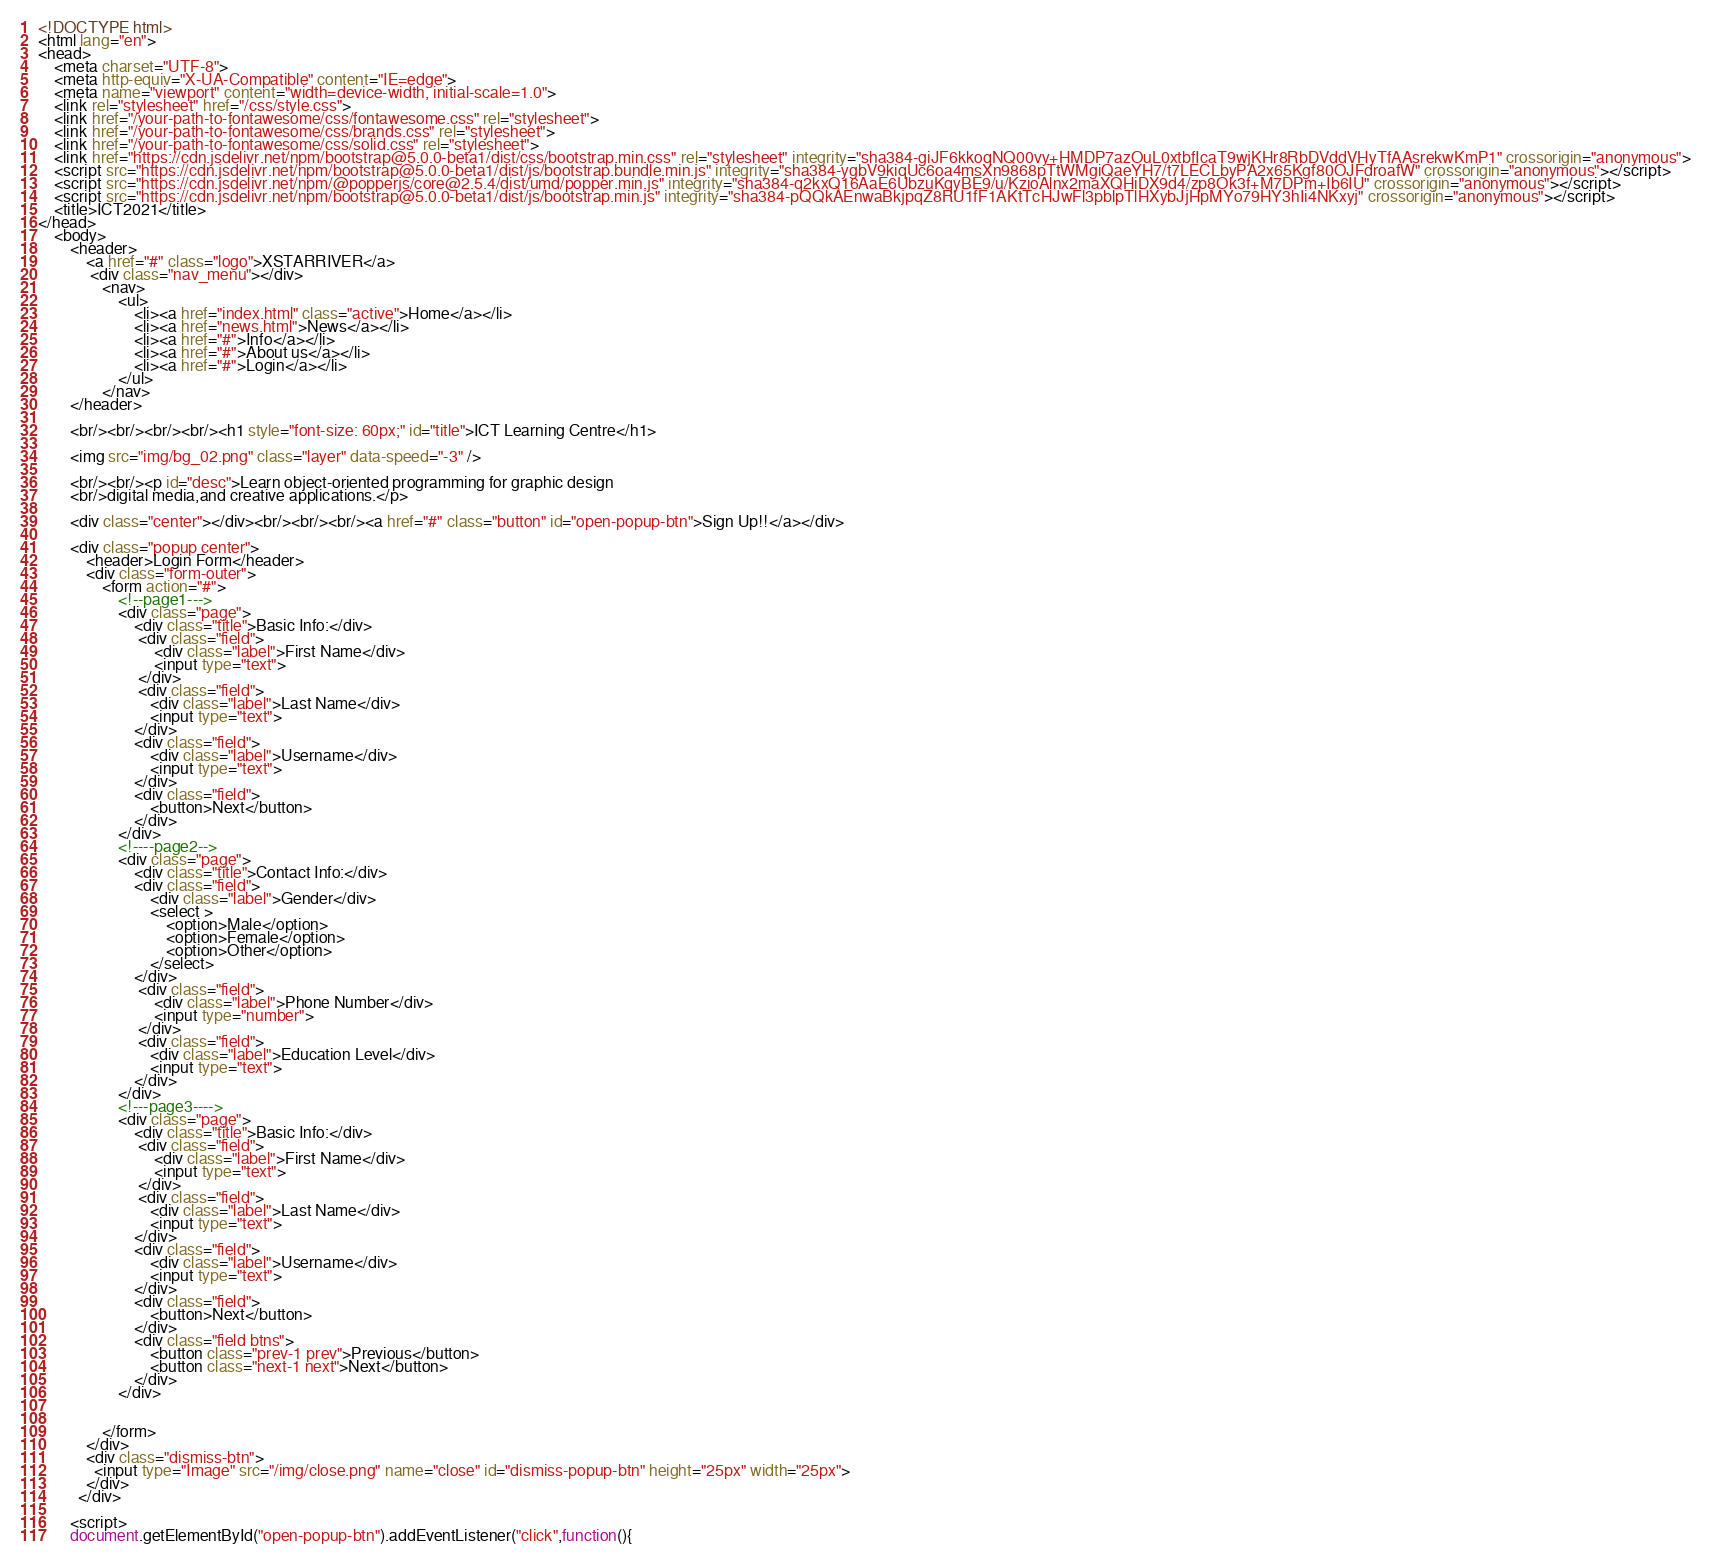Convert code to text. <code><loc_0><loc_0><loc_500><loc_500><_HTML_><!DOCTYPE html>
<html lang="en">
<head>
    <meta charset="UTF-8">
    <meta http-equiv="X-UA-Compatible" content="IE=edge">
    <meta name="viewport" content="width=device-width, initial-scale=1.0">
    <link rel="stylesheet" href="/css/style.css">
    <link href="/your-path-to-fontawesome/css/fontawesome.css" rel="stylesheet">
    <link href="/your-path-to-fontawesome/css/brands.css" rel="stylesheet">
    <link href="/your-path-to-fontawesome/css/solid.css" rel="stylesheet">
    <link href="https://cdn.jsdelivr.net/npm/bootstrap@5.0.0-beta1/dist/css/bootstrap.min.css" rel="stylesheet" integrity="sha384-giJF6kkoqNQ00vy+HMDP7azOuL0xtbfIcaT9wjKHr8RbDVddVHyTfAAsrekwKmP1" crossorigin="anonymous">
    <script src="https://cdn.jsdelivr.net/npm/bootstrap@5.0.0-beta1/dist/js/bootstrap.bundle.min.js" integrity="sha384-ygbV9kiqUc6oa4msXn9868pTtWMgiQaeYH7/t7LECLbyPA2x65Kgf80OJFdroafW" crossorigin="anonymous"></script>
    <script src="https://cdn.jsdelivr.net/npm/@popperjs/core@2.5.4/dist/umd/popper.min.js" integrity="sha384-q2kxQ16AaE6UbzuKqyBE9/u/KzioAlnx2maXQHiDX9d4/zp8Ok3f+M7DPm+Ib6IU" crossorigin="anonymous"></script>
    <script src="https://cdn.jsdelivr.net/npm/bootstrap@5.0.0-beta1/dist/js/bootstrap.min.js" integrity="sha384-pQQkAEnwaBkjpqZ8RU1fF1AKtTcHJwFl3pblpTlHXybJjHpMYo79HY3hIi4NKxyj" crossorigin="anonymous"></script>
    <title>ICT2021</title>
</head>
    <body>
        <header> 
            <a href="#" class="logo">XSTARRIVER</a>
             <div class="nav_menu"></div>
                <nav>
                    <ul>
                        <li><a href="index.html" class="active">Home</a></li>
                        <li><a href="news.html">News</a></li>
                        <li><a href="#">Info</a></li>
                        <li><a href="#">About us</a></li>
                        <li><a href="#">Login</a></li>
                    </ul>
                </nav>
        </header>
        
        <br/><br/><br/><br/><h1 style="font-size: 60px;" id="title">ICT Learning Centre</h1>

        <img src="img/bg_02.png" class="layer" data-speed="-3" />

        <br/><br/><p id="desc">Learn object-oriented programming for graphic design
        <br/>digital media,and creative applications.</p>

        <div class="center"></div><br/><br/><br/><a href="#" class="button" id="open-popup-btn">Sign Up!!</a></div>

        <div class="popup center">
            <header>Login Form</header>
            <div class="form-outer">
                <form action="#">
                    <!--page1--->
                    <div class="page">
                        <div class="title">Basic Info:</div>
                         <div class="field">
                             <div class="label">First Name</div>
                             <input type="text">
                         </div>
                         <div class="field">
                            <div class="label">Last Name</div>
                            <input type="text">
                        </div>
                        <div class="field">
                            <div class="label">Username</div>
                            <input type="text">
                        </div>
                        <div class="field">
                            <button>Next</button>
                        </div>   
                    </div>
                    <!----page2-->
                    <div class="page">
                        <div class="title">Contact Info:</div>
                        <div class="field">
                            <div class="label">Gender</div>
                            <select >
                                <option>Male</option>
                                <option>Female</option>
                                <option>Other</option>
                            </select>
                        </div>
                         <div class="field">
                             <div class="label">Phone Number</div>
                             <input type="number">
                         </div> 
                         <div class="field">
                            <div class="label">Education Level</div>
                            <input type="text">
                        </div>
                    </div>
                    <!---page3---->
                    <div class="page">
                        <div class="title">Basic Info:</div>
                         <div class="field">
                             <div class="label">First Name</div>
                             <input type="text">
                         </div>
                         <div class="field">
                            <div class="label">Last Name</div>
                            <input type="text">
                        </div>
                        <div class="field">
                            <div class="label">Username</div>
                            <input type="text">
                        </div>
                        <div class="field">
                            <button>Next</button>
                        </div>   
                        <div class="field btns">
                            <button class="prev-1 prev">Previous</button>
                            <button class="next-1 next">Next</button>
                        </div>   
                    </div>


                </form>
            </div>
            <div class="dismiss-btn">
              <input type="Image" src="/img/close.png" name="close" id="dismiss-popup-btn" height="25px" width="25px">
            </div>
          </div>

        <script>
        document.getElementById("open-popup-btn").addEventListener("click",function(){</code> 